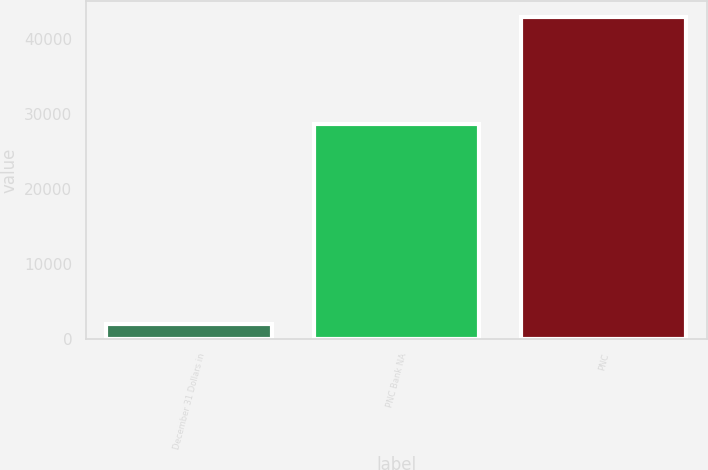<chart> <loc_0><loc_0><loc_500><loc_500><bar_chart><fcel>December 31 Dollars in<fcel>PNC Bank NA<fcel>PNC<nl><fcel>2013<fcel>28731<fcel>42950<nl></chart> 